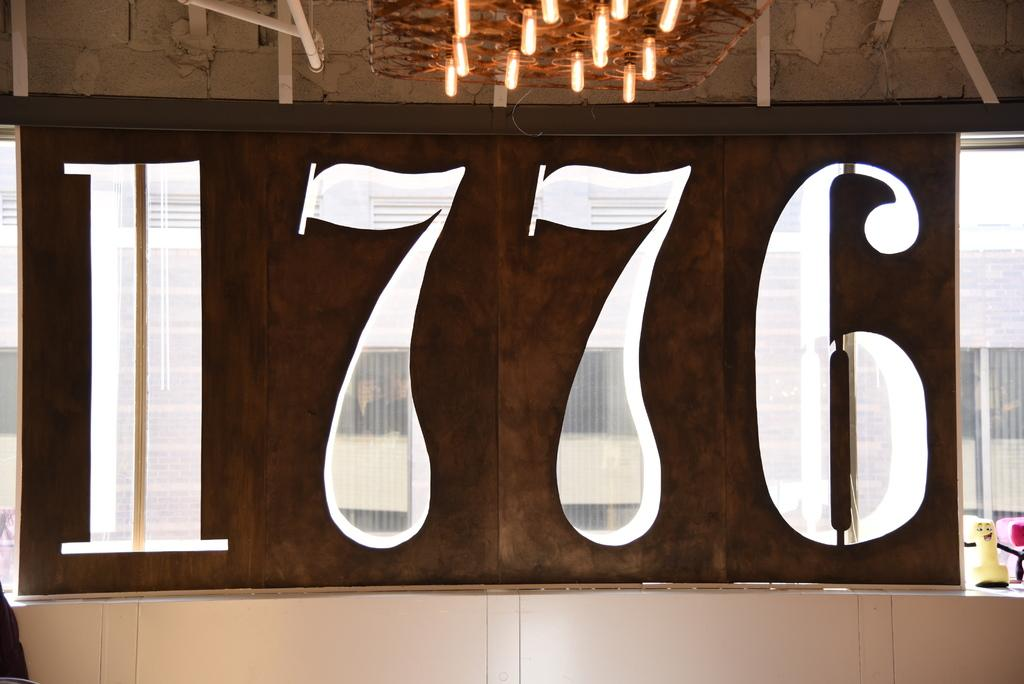What is the color and material of the wall in the image? The wall in the image is a brown color wooden wall. Are there any markings or text on the wall? Yes, there are numbers (1776) in white color on the wall. What can be seen at the top of the image? There are lights visible at the top of the image. What type of cub is sitting in the middle of the image? There is no cub present in the image. How many quinces are visible on the wooden wall? There are no quinces visible on the wooden wall; only the numbers (1776) are present. 